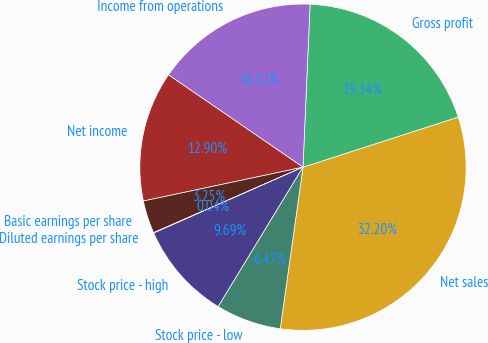Convert chart. <chart><loc_0><loc_0><loc_500><loc_500><pie_chart><fcel>Net sales<fcel>Gross profit<fcel>Income from operations<fcel>Net income<fcel>Basic earnings per share<fcel>Diluted earnings per share<fcel>Stock price - high<fcel>Stock price - low<nl><fcel>32.2%<fcel>19.34%<fcel>16.12%<fcel>12.9%<fcel>3.25%<fcel>0.04%<fcel>9.69%<fcel>6.47%<nl></chart> 